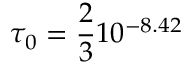Convert formula to latex. <formula><loc_0><loc_0><loc_500><loc_500>\tau _ { 0 } = \frac { 2 } { 3 } 1 0 ^ { - 8 . 4 2 }</formula> 